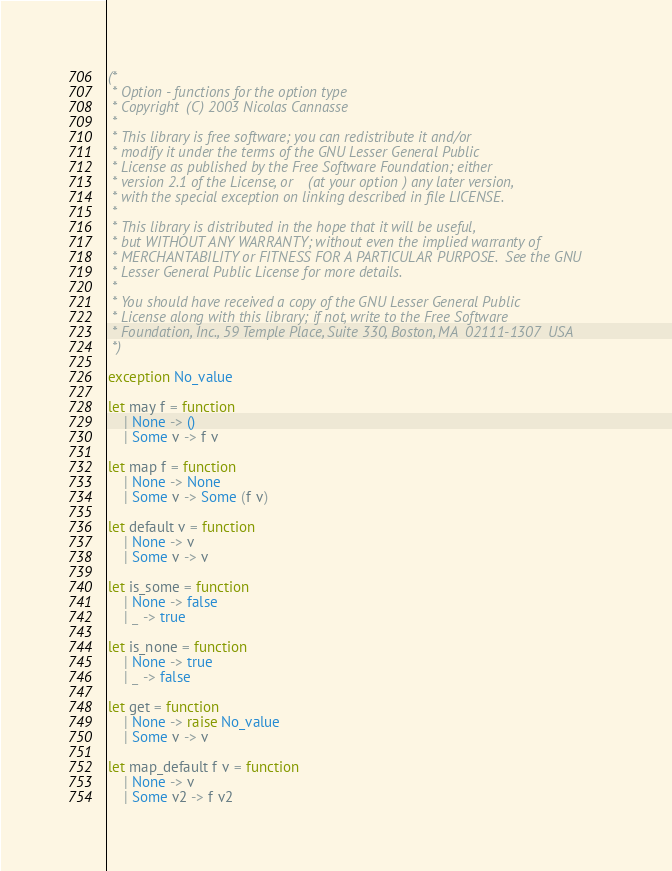Convert code to text. <code><loc_0><loc_0><loc_500><loc_500><_OCaml_>(*
 * Option - functions for the option type
 * Copyright (C) 2003 Nicolas Cannasse
 * 
 * This library is free software; you can redistribute it and/or
 * modify it under the terms of the GNU Lesser General Public
 * License as published by the Free Software Foundation; either
 * version 2.1 of the License, or (at your option) any later version,
 * with the special exception on linking described in file LICENSE.
 *
 * This library is distributed in the hope that it will be useful,
 * but WITHOUT ANY WARRANTY; without even the implied warranty of
 * MERCHANTABILITY or FITNESS FOR A PARTICULAR PURPOSE.  See the GNU
 * Lesser General Public License for more details.
 *
 * You should have received a copy of the GNU Lesser General Public
 * License along with this library; if not, write to the Free Software
 * Foundation, Inc., 59 Temple Place, Suite 330, Boston, MA  02111-1307  USA
 *)
 
exception No_value

let may f = function
	| None -> ()
	| Some v -> f v

let map f = function
	| None -> None
	| Some v -> Some (f v)

let default v = function
	| None -> v
	| Some v -> v

let is_some = function
	| None -> false
	| _ -> true

let is_none = function
	| None -> true
	| _ -> false

let get = function
	| None -> raise No_value
	| Some v -> v

let map_default f v = function
	| None -> v
	| Some v2 -> f v2
</code> 